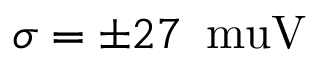<formula> <loc_0><loc_0><loc_500><loc_500>\sigma = \pm 2 7 \, \ m u V</formula> 